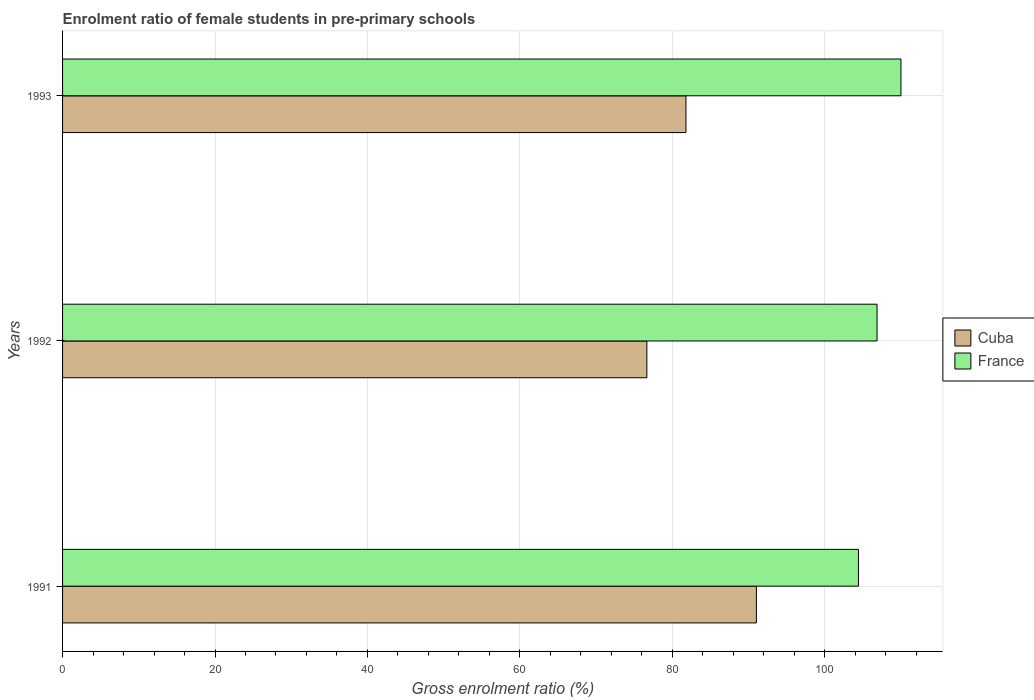How many groups of bars are there?
Offer a terse response. 3. Are the number of bars per tick equal to the number of legend labels?
Your answer should be compact. Yes. Are the number of bars on each tick of the Y-axis equal?
Provide a succinct answer. Yes. How many bars are there on the 2nd tick from the top?
Offer a very short reply. 2. What is the label of the 2nd group of bars from the top?
Your response must be concise. 1992. What is the enrolment ratio of female students in pre-primary schools in Cuba in 1993?
Give a very brief answer. 81.79. Across all years, what is the maximum enrolment ratio of female students in pre-primary schools in France?
Your answer should be very brief. 110. Across all years, what is the minimum enrolment ratio of female students in pre-primary schools in Cuba?
Offer a very short reply. 76.66. In which year was the enrolment ratio of female students in pre-primary schools in Cuba minimum?
Give a very brief answer. 1992. What is the total enrolment ratio of female students in pre-primary schools in France in the graph?
Provide a succinct answer. 321.3. What is the difference between the enrolment ratio of female students in pre-primary schools in Cuba in 1991 and that in 1992?
Offer a terse response. 14.37. What is the difference between the enrolment ratio of female students in pre-primary schools in Cuba in 1993 and the enrolment ratio of female students in pre-primary schools in France in 1991?
Your answer should be compact. -22.64. What is the average enrolment ratio of female students in pre-primary schools in France per year?
Keep it short and to the point. 107.1. In the year 1993, what is the difference between the enrolment ratio of female students in pre-primary schools in France and enrolment ratio of female students in pre-primary schools in Cuba?
Keep it short and to the point. 28.21. What is the ratio of the enrolment ratio of female students in pre-primary schools in France in 1992 to that in 1993?
Offer a terse response. 0.97. Is the enrolment ratio of female students in pre-primary schools in Cuba in 1991 less than that in 1992?
Your response must be concise. No. What is the difference between the highest and the second highest enrolment ratio of female students in pre-primary schools in Cuba?
Offer a very short reply. 9.24. What is the difference between the highest and the lowest enrolment ratio of female students in pre-primary schools in France?
Offer a very short reply. 5.57. In how many years, is the enrolment ratio of female students in pre-primary schools in Cuba greater than the average enrolment ratio of female students in pre-primary schools in Cuba taken over all years?
Your answer should be compact. 1. What does the 2nd bar from the top in 1991 represents?
Your answer should be very brief. Cuba. What does the 2nd bar from the bottom in 1991 represents?
Your answer should be compact. France. Are all the bars in the graph horizontal?
Offer a terse response. Yes. How many years are there in the graph?
Provide a succinct answer. 3. What is the difference between two consecutive major ticks on the X-axis?
Your response must be concise. 20. Are the values on the major ticks of X-axis written in scientific E-notation?
Your answer should be compact. No. Does the graph contain grids?
Offer a very short reply. Yes. How many legend labels are there?
Ensure brevity in your answer.  2. How are the legend labels stacked?
Your answer should be very brief. Vertical. What is the title of the graph?
Your answer should be very brief. Enrolment ratio of female students in pre-primary schools. What is the Gross enrolment ratio (%) of Cuba in 1991?
Your answer should be very brief. 91.03. What is the Gross enrolment ratio (%) in France in 1991?
Your answer should be compact. 104.43. What is the Gross enrolment ratio (%) of Cuba in 1992?
Your response must be concise. 76.66. What is the Gross enrolment ratio (%) of France in 1992?
Make the answer very short. 106.87. What is the Gross enrolment ratio (%) of Cuba in 1993?
Your answer should be compact. 81.79. What is the Gross enrolment ratio (%) of France in 1993?
Your answer should be very brief. 110. Across all years, what is the maximum Gross enrolment ratio (%) of Cuba?
Provide a succinct answer. 91.03. Across all years, what is the maximum Gross enrolment ratio (%) of France?
Provide a succinct answer. 110. Across all years, what is the minimum Gross enrolment ratio (%) of Cuba?
Make the answer very short. 76.66. Across all years, what is the minimum Gross enrolment ratio (%) of France?
Offer a terse response. 104.43. What is the total Gross enrolment ratio (%) in Cuba in the graph?
Offer a terse response. 249.49. What is the total Gross enrolment ratio (%) of France in the graph?
Offer a very short reply. 321.3. What is the difference between the Gross enrolment ratio (%) of Cuba in 1991 and that in 1992?
Keep it short and to the point. 14.37. What is the difference between the Gross enrolment ratio (%) in France in 1991 and that in 1992?
Your answer should be compact. -2.44. What is the difference between the Gross enrolment ratio (%) of Cuba in 1991 and that in 1993?
Offer a terse response. 9.24. What is the difference between the Gross enrolment ratio (%) in France in 1991 and that in 1993?
Your answer should be very brief. -5.57. What is the difference between the Gross enrolment ratio (%) of Cuba in 1992 and that in 1993?
Your answer should be compact. -5.13. What is the difference between the Gross enrolment ratio (%) of France in 1992 and that in 1993?
Provide a succinct answer. -3.14. What is the difference between the Gross enrolment ratio (%) of Cuba in 1991 and the Gross enrolment ratio (%) of France in 1992?
Ensure brevity in your answer.  -15.83. What is the difference between the Gross enrolment ratio (%) of Cuba in 1991 and the Gross enrolment ratio (%) of France in 1993?
Your response must be concise. -18.97. What is the difference between the Gross enrolment ratio (%) of Cuba in 1992 and the Gross enrolment ratio (%) of France in 1993?
Provide a short and direct response. -33.34. What is the average Gross enrolment ratio (%) in Cuba per year?
Give a very brief answer. 83.16. What is the average Gross enrolment ratio (%) in France per year?
Offer a very short reply. 107.1. In the year 1991, what is the difference between the Gross enrolment ratio (%) of Cuba and Gross enrolment ratio (%) of France?
Your answer should be compact. -13.4. In the year 1992, what is the difference between the Gross enrolment ratio (%) in Cuba and Gross enrolment ratio (%) in France?
Provide a succinct answer. -30.2. In the year 1993, what is the difference between the Gross enrolment ratio (%) in Cuba and Gross enrolment ratio (%) in France?
Offer a terse response. -28.21. What is the ratio of the Gross enrolment ratio (%) of Cuba in 1991 to that in 1992?
Offer a very short reply. 1.19. What is the ratio of the Gross enrolment ratio (%) in France in 1991 to that in 1992?
Give a very brief answer. 0.98. What is the ratio of the Gross enrolment ratio (%) in Cuba in 1991 to that in 1993?
Your response must be concise. 1.11. What is the ratio of the Gross enrolment ratio (%) of France in 1991 to that in 1993?
Your answer should be compact. 0.95. What is the ratio of the Gross enrolment ratio (%) of Cuba in 1992 to that in 1993?
Ensure brevity in your answer.  0.94. What is the ratio of the Gross enrolment ratio (%) in France in 1992 to that in 1993?
Ensure brevity in your answer.  0.97. What is the difference between the highest and the second highest Gross enrolment ratio (%) of Cuba?
Offer a terse response. 9.24. What is the difference between the highest and the second highest Gross enrolment ratio (%) of France?
Your answer should be compact. 3.14. What is the difference between the highest and the lowest Gross enrolment ratio (%) in Cuba?
Your answer should be compact. 14.37. What is the difference between the highest and the lowest Gross enrolment ratio (%) of France?
Keep it short and to the point. 5.57. 